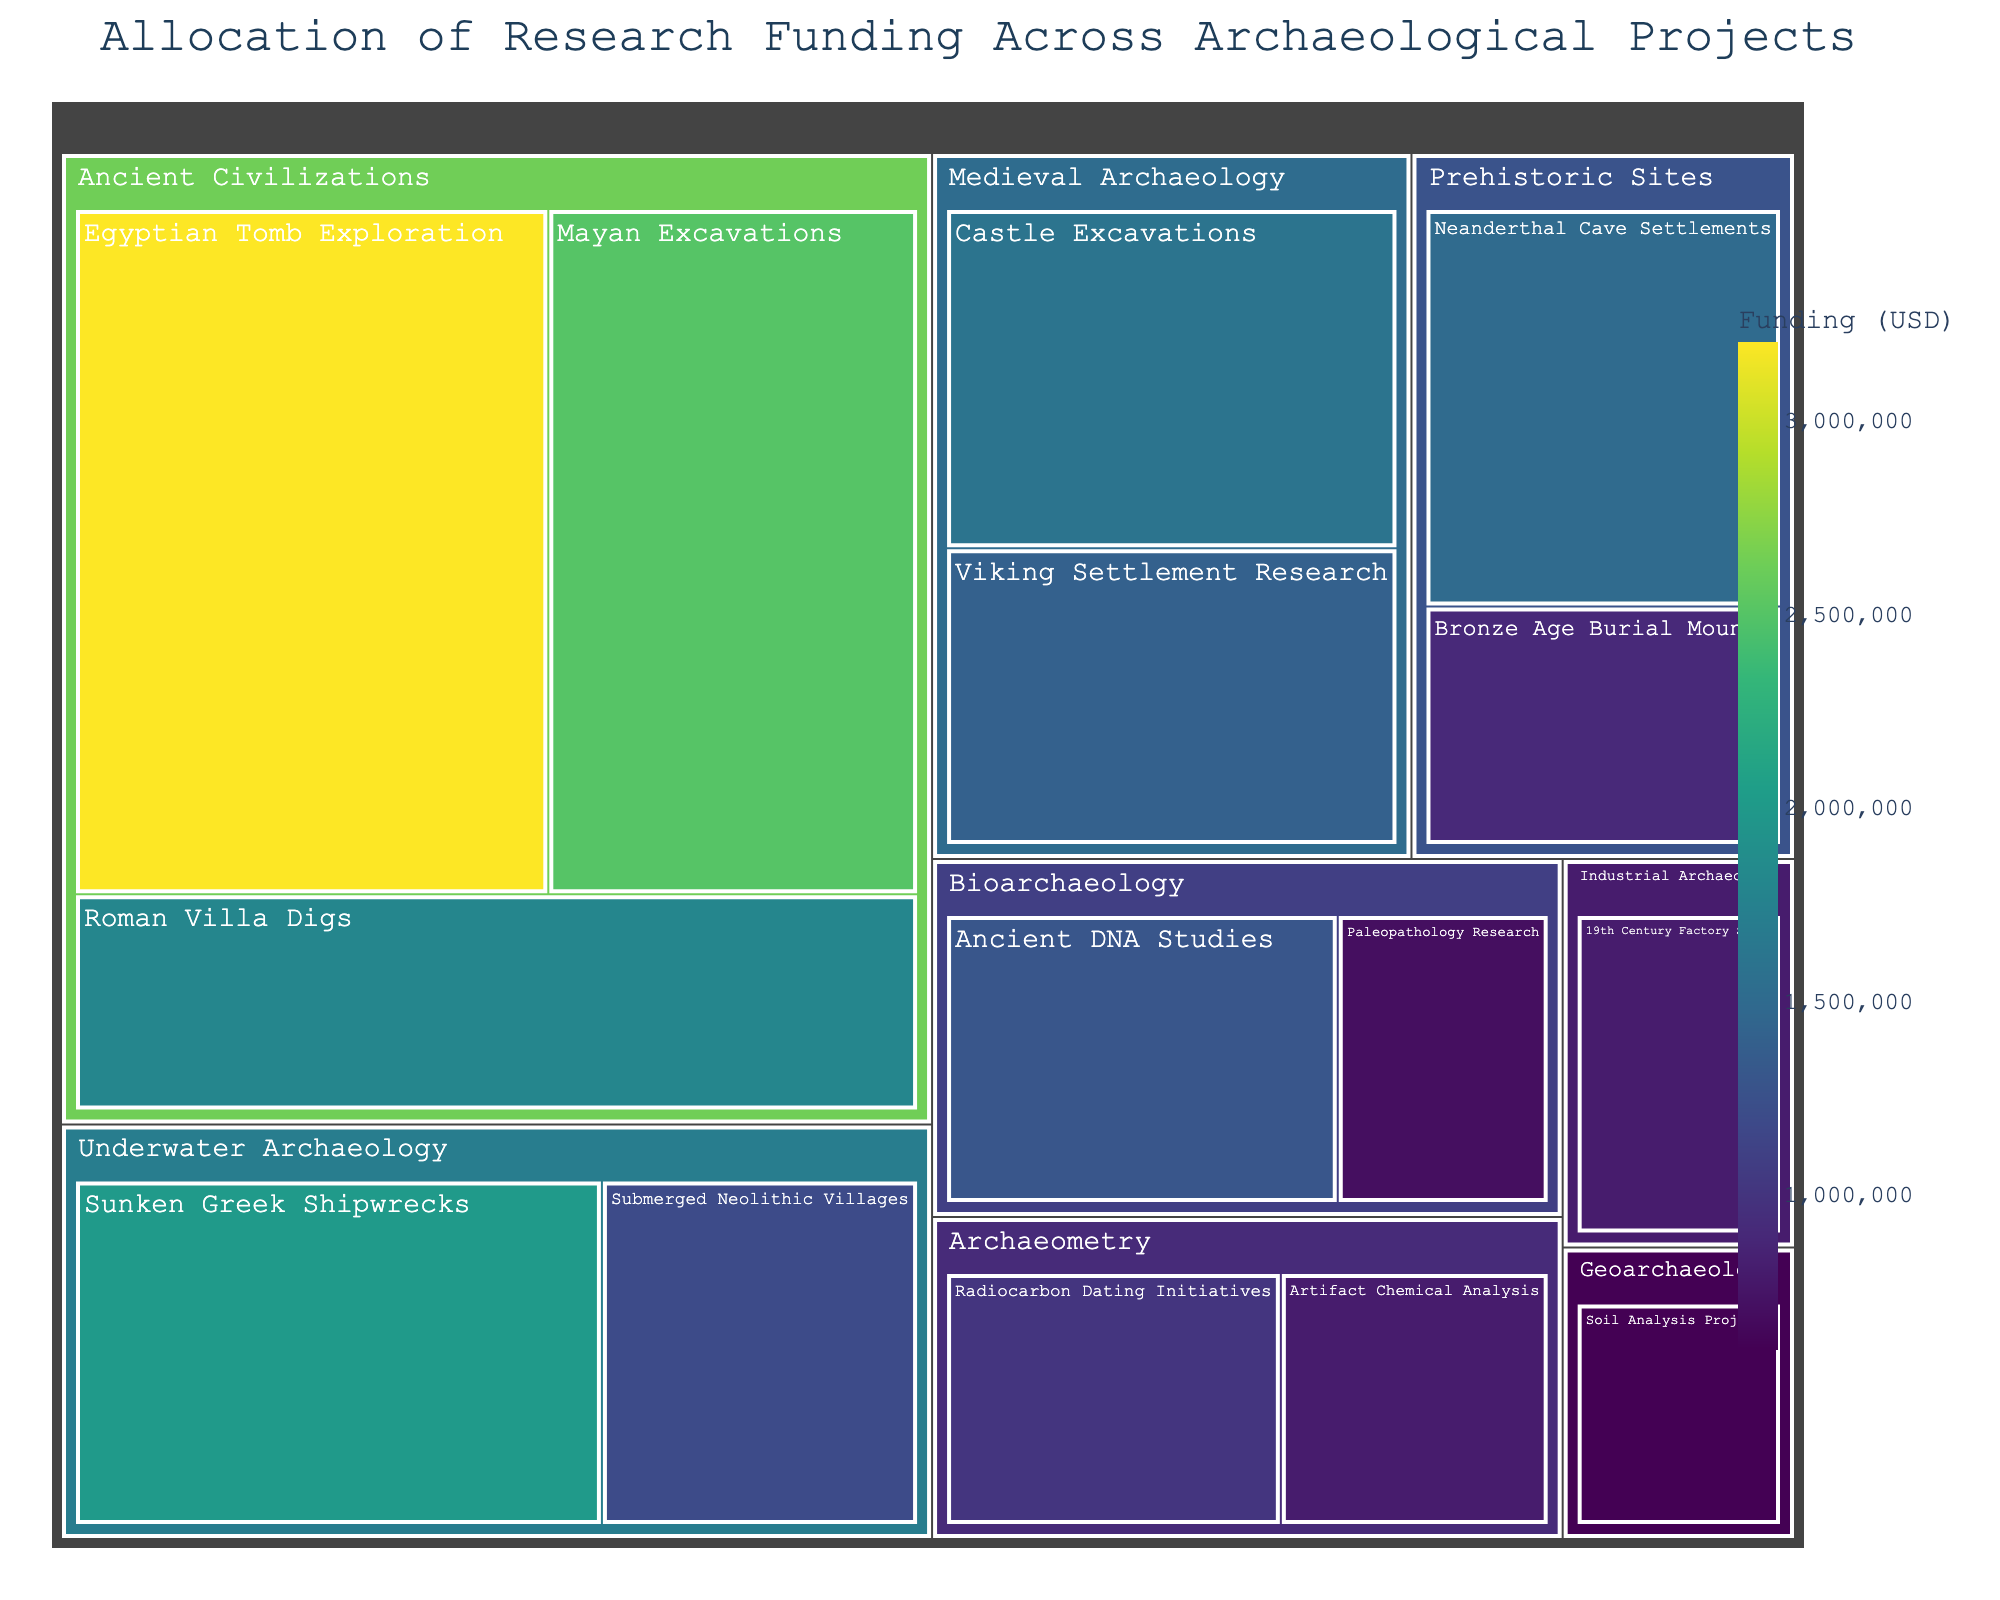What is the total funding allocated for Ancient Civilizations? To find the total funding for the category Ancient Civilizations, sum all the subcategory funding: Mayan Excavations (2,500,000) + Roman Villa Digs (1,800,000) + Egyptian Tomb Exploration (3,200,000). Hence, 2,500,000 + 1,800,000 + 3,200,000 = 7,500,000.
Answer: 7,500,000 Which subcategory received the highest funding? Identify the largest funding amount visually on the treemap by looking for the largest section. The Egyptian Tomb Exploration has the highest funding at 3,200,000.
Answer: Egyptian Tomb Exploration Compare the total funding between Prehistoric Sites and Underwater Archaeology. Which category has more funding? Sum the funding for the subcategories in each category: Prehistoric Sites (Neanderthal Cave Settlements: 1,500,000 + Bronze Age Burial Mounds: 900,000) equals 2,400,000, and Underwater Archaeology (Sunken Greek Shipwrecks: 2,000,000 + Submerged Neolithic Villages: 1,200,000) equals 3,200,000. Therefore, Underwater Archaeology has more funding.
Answer: Underwater Archaeology What is the average funding for the subcategories under Medieval Archaeology? Calculate by summing the funding for the subcategories (Castle Excavations: 1,600,000 + Viking Settlement Research: 1,400,000) and then divide by the number of subcategories. Hence, (1,600,000 + 1,400,000) / 2 = 1,500,000.
Answer: 1,500,000 Which category has the least funding and what is the amount? Find the smallest segment in the treemap. Geoarchaeology has the least funding with 600,000.
Answer: Geoarchaeology, 600,000 How much more funding does Egyptian Tomb Exploration have compared to Neanderthal Cave Settlements? Subtract the funding for Neanderthal Cave Settlements from Egyptian Tomb Exploration: 3,200,000 - 1,500,000 = 1,700,000.
Answer: 1,700,000 What is the total funding allocated for Archaeometry? Sum the funding for the subcategories within Archaeometry: Radiocarbon Dating Initiatives (1,000,000) + Artifact Chemical Analysis (800,000). Hence, 1,000,000 + 800,000 = 1,800,000.
Answer: 1,800,000 Which category has more funding: Bioarchaeology or Medieval Archaeology? Sum the funding for Bioarchaeology (Ancient DNA Studies: 1,300,000 + Paleopathology Research: 700,000) to get 2,000,000. Sum the funding for Medieval Archaeology (Castle Excavations: 1,600,000 + Viking Settlement Research: 1,400,000) to get 3,000,000. Medieval Archaeology has more funding.
Answer: Medieval Archaeology What is the funding difference between the highest and lowest funded subcategories? The highest funded subcategory is Egyptian Tomb Exploration (3,200,000), and the lowest funded subcategory is Soil Analysis Projects (600,000). The difference is 3,200,000 - 600,000 = 2,600,000.
Answer: 2,600,000 